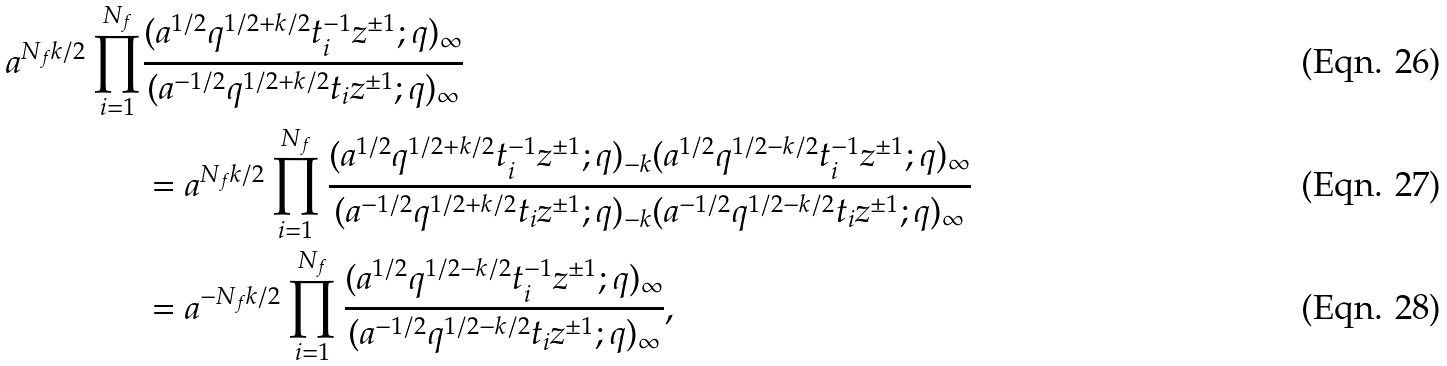Convert formula to latex. <formula><loc_0><loc_0><loc_500><loc_500>a ^ { N _ { f } k / 2 } \prod _ { i = 1 } ^ { N _ { f } } & \frac { ( a ^ { 1 / 2 } q ^ { 1 / 2 + k / 2 } t _ { i } ^ { - 1 } z ^ { \pm 1 } ; q ) _ { \infty } } { ( a ^ { - 1 / 2 } q ^ { 1 / 2 + k / 2 } t _ { i } z ^ { \pm 1 } ; q ) _ { \infty } } \\ & = a ^ { N _ { f } k / 2 } \prod _ { i = 1 } ^ { N _ { f } } \frac { ( a ^ { 1 / 2 } q ^ { 1 / 2 + k / 2 } t _ { i } ^ { - 1 } z ^ { \pm 1 } ; q ) _ { - k } ( a ^ { 1 / 2 } q ^ { 1 / 2 - k / 2 } t _ { i } ^ { - 1 } z ^ { \pm 1 } ; q ) _ { \infty } } { ( a ^ { - 1 / 2 } q ^ { 1 / 2 + k / 2 } t _ { i } z ^ { \pm 1 } ; q ) _ { - k } ( a ^ { - 1 / 2 } q ^ { 1 / 2 - k / 2 } t _ { i } z ^ { \pm 1 } ; q ) _ { \infty } } \\ & = a ^ { - N _ { f } k / 2 } \prod _ { i = 1 } ^ { N _ { f } } \frac { ( a ^ { 1 / 2 } q ^ { 1 / 2 - k / 2 } t _ { i } ^ { - 1 } z ^ { \pm 1 } ; q ) _ { \infty } } { ( a ^ { - 1 / 2 } q ^ { 1 / 2 - k / 2 } t _ { i } z ^ { \pm 1 } ; q ) _ { \infty } } ,</formula> 